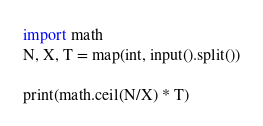<code> <loc_0><loc_0><loc_500><loc_500><_Python_>import math
N, X, T = map(int, input().split())

print(math.ceil(N/X) * T)
</code> 